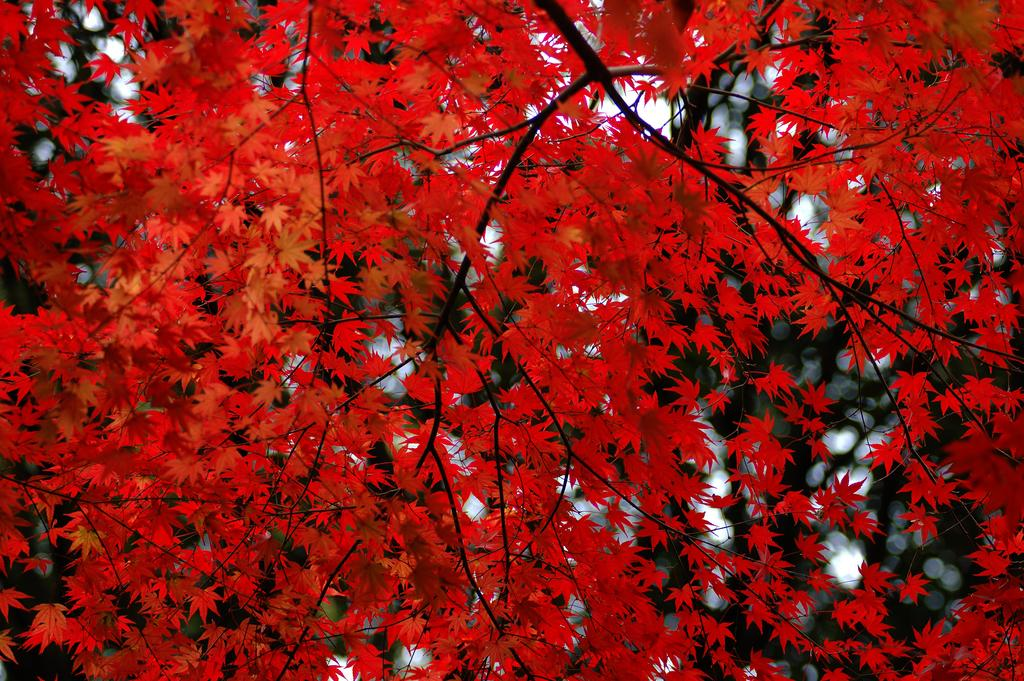What is the main subject of the image? There is a tree in the image. What type of leaves does the tree have? The tree has red maple leaves. How would you describe the background of the image? The background of the image is blurred. What type of education is being offered by the tree in the image? There is no indication in the image that the tree is offering any type of education. 